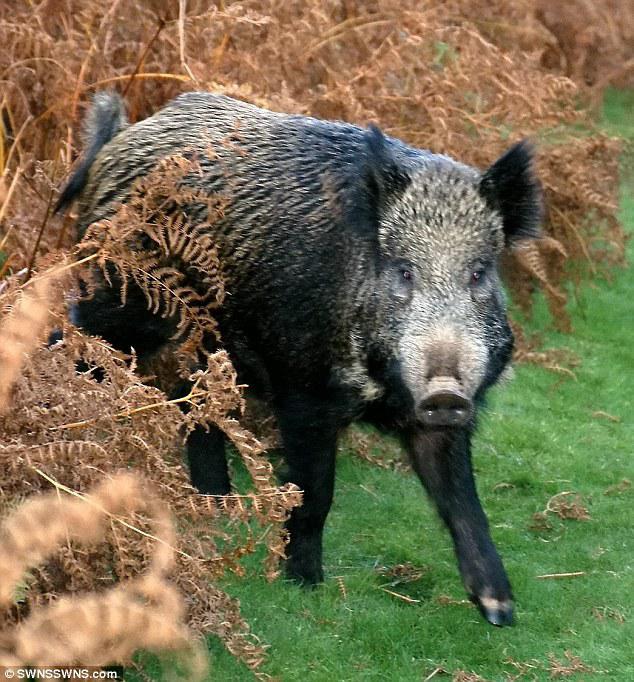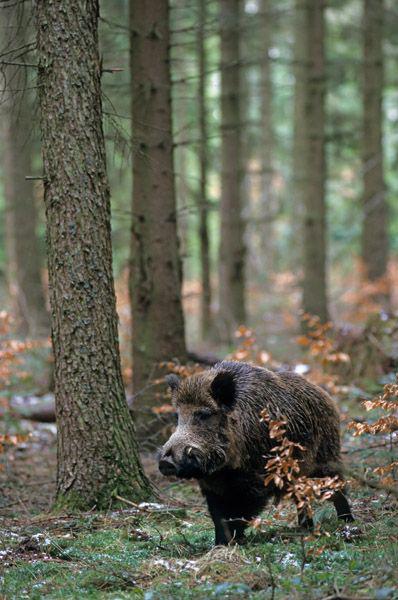The first image is the image on the left, the second image is the image on the right. Examine the images to the left and right. Is the description "a lone wartgog is standing in the water" accurate? Answer yes or no. No. The first image is the image on the left, the second image is the image on the right. For the images displayed, is the sentence "There are two pigs." factually correct? Answer yes or no. Yes. 